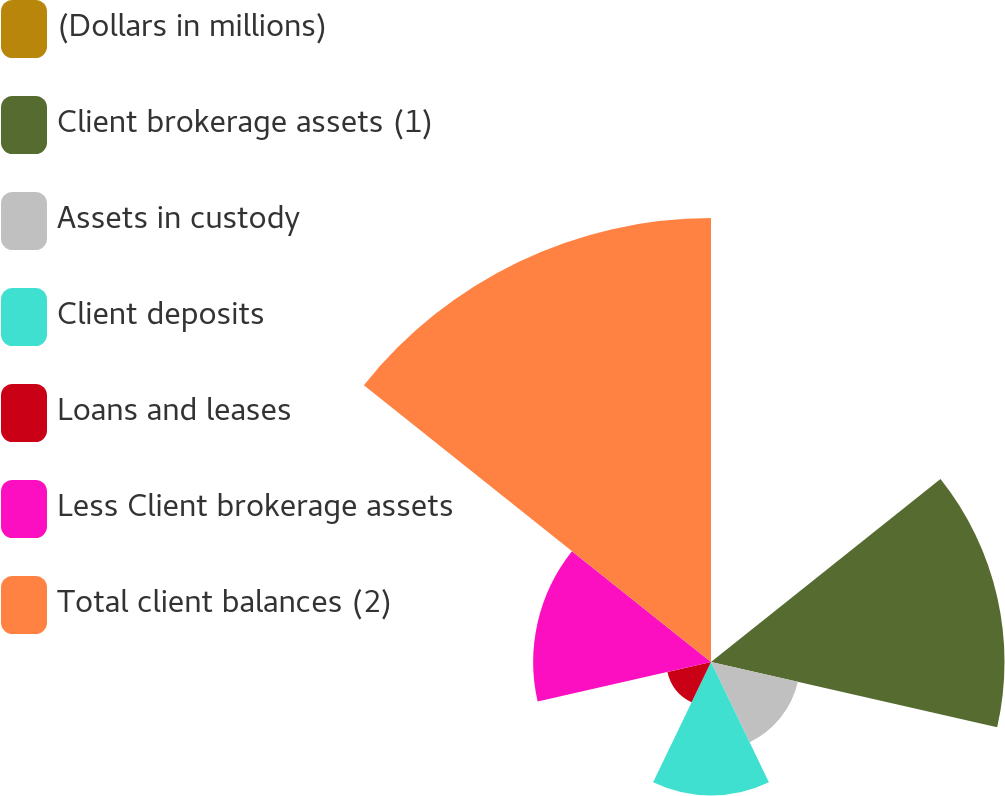Convert chart. <chart><loc_0><loc_0><loc_500><loc_500><pie_chart><fcel>(Dollars in millions)<fcel>Client brokerage assets (1)<fcel>Assets in custody<fcel>Client deposits<fcel>Loans and leases<fcel>Less Client brokerage assets<fcel>Total client balances (2)<nl><fcel>0.03%<fcel>24.81%<fcel>7.53%<fcel>11.28%<fcel>3.78%<fcel>15.03%<fcel>37.53%<nl></chart> 